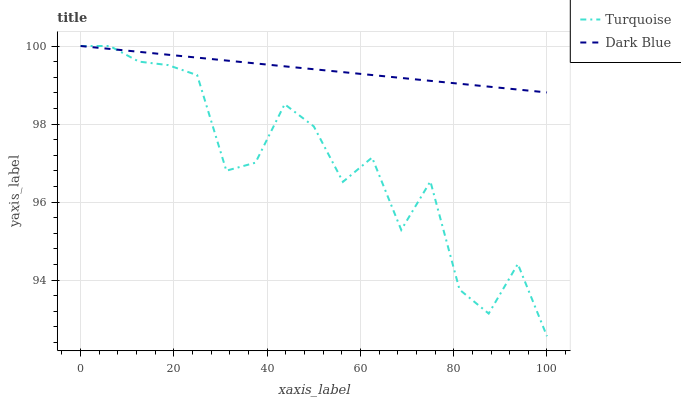Does Turquoise have the minimum area under the curve?
Answer yes or no. Yes. Does Dark Blue have the maximum area under the curve?
Answer yes or no. Yes. Does Turquoise have the maximum area under the curve?
Answer yes or no. No. Is Dark Blue the smoothest?
Answer yes or no. Yes. Is Turquoise the roughest?
Answer yes or no. Yes. Is Turquoise the smoothest?
Answer yes or no. No. Does Turquoise have the lowest value?
Answer yes or no. Yes. Does Turquoise have the highest value?
Answer yes or no. Yes. Does Dark Blue intersect Turquoise?
Answer yes or no. Yes. Is Dark Blue less than Turquoise?
Answer yes or no. No. Is Dark Blue greater than Turquoise?
Answer yes or no. No. 